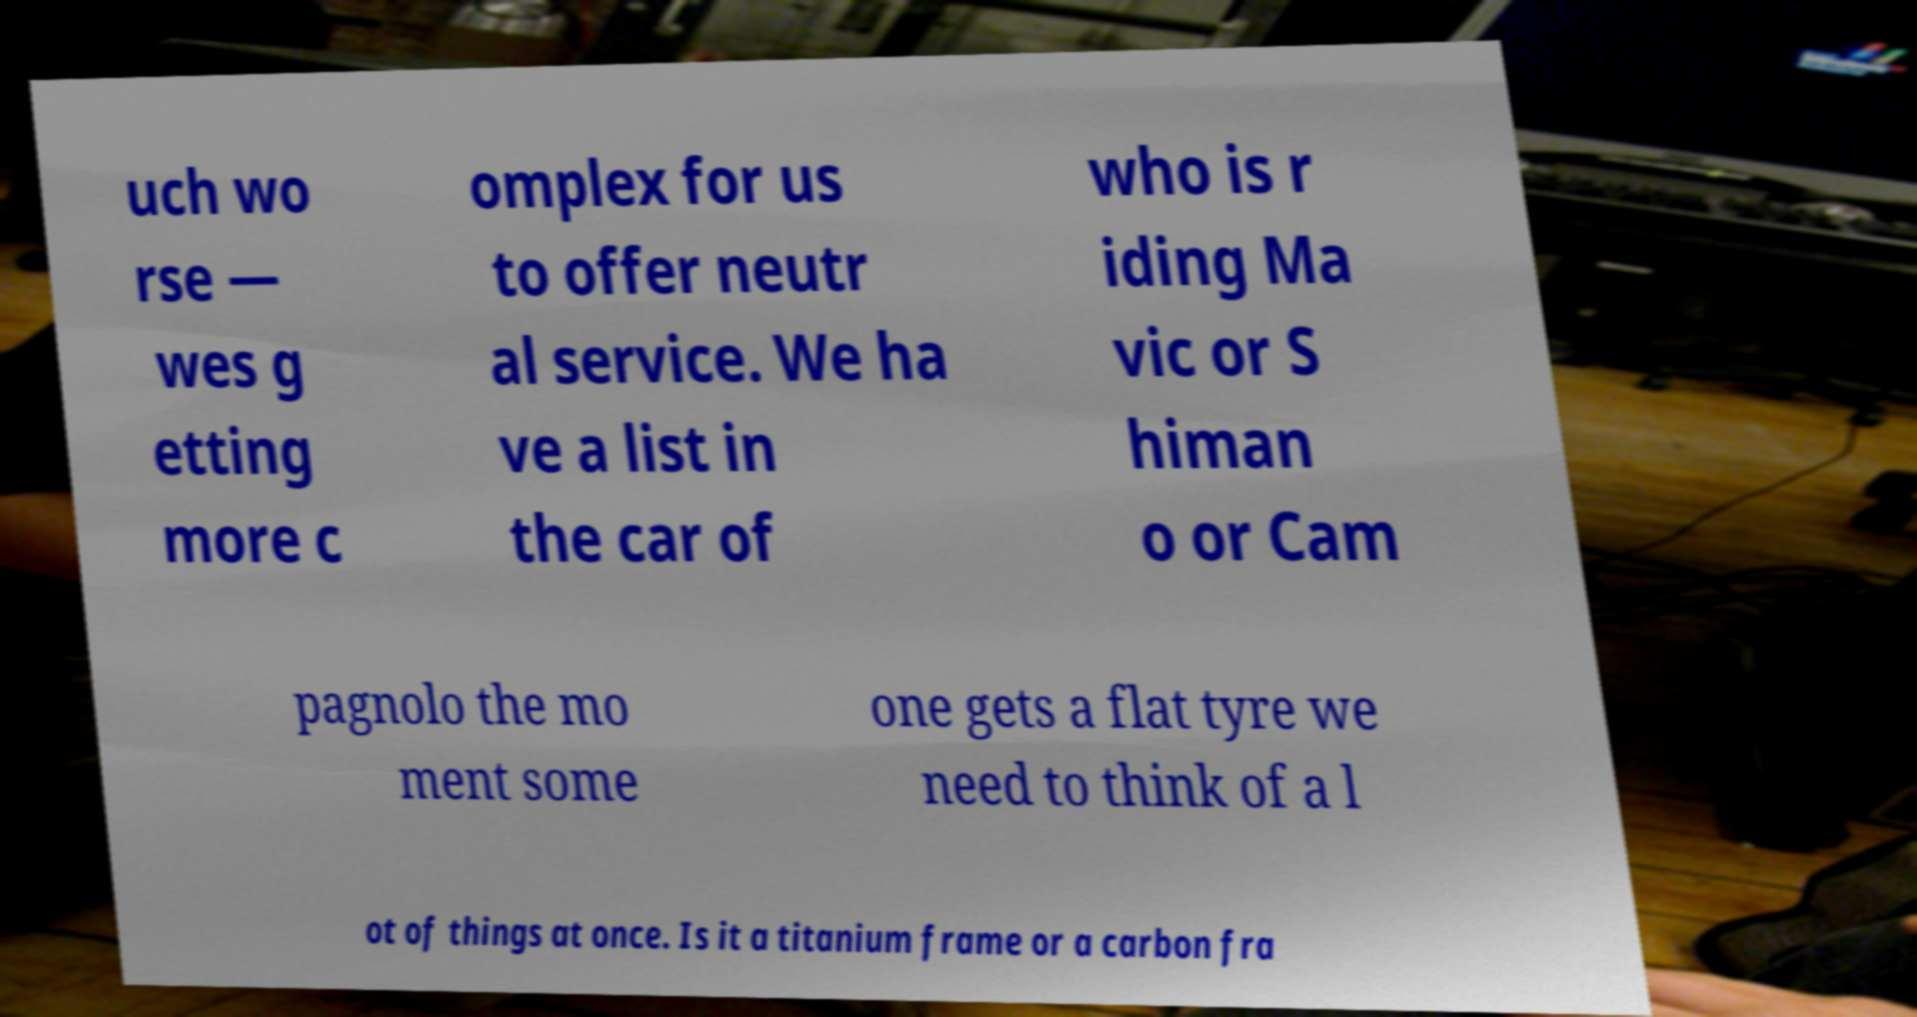Could you assist in decoding the text presented in this image and type it out clearly? uch wo rse — wes g etting more c omplex for us to offer neutr al service. We ha ve a list in the car of who is r iding Ma vic or S himan o or Cam pagnolo the mo ment some one gets a flat tyre we need to think of a l ot of things at once. Is it a titanium frame or a carbon fra 